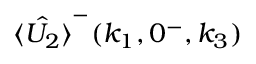<formula> <loc_0><loc_0><loc_500><loc_500>\hat { \langle U _ { 2 } \rangle } ^ { - } ( k _ { 1 } , 0 ^ { - } , k _ { 3 } )</formula> 